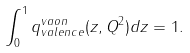Convert formula to latex. <formula><loc_0><loc_0><loc_500><loc_500>\int ^ { 1 } _ { 0 } q _ { v a l e n c e } ^ { v a o n } ( z , Q ^ { 2 } ) d z = 1 .</formula> 